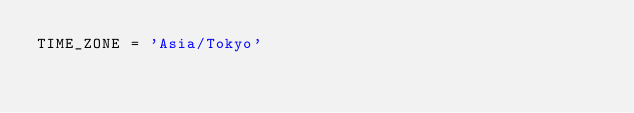<code> <loc_0><loc_0><loc_500><loc_500><_Python_>TIME_ZONE = 'Asia/Tokyo'


</code> 